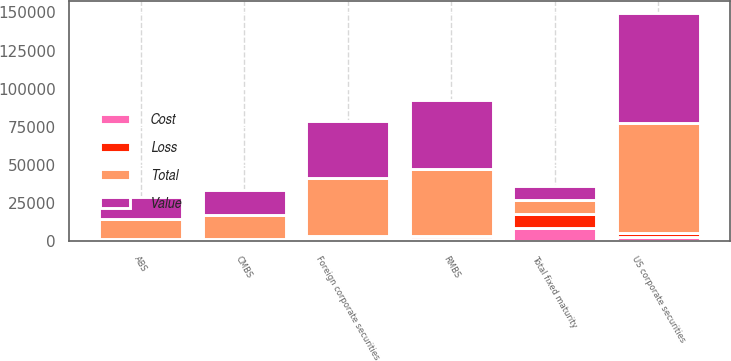Convert chart to OTSL. <chart><loc_0><loc_0><loc_500><loc_500><stacked_bar_chart><ecel><fcel>US corporate securities<fcel>Foreign corporate securities<fcel>RMBS<fcel>CMBS<fcel>ABS<fcel>Total fixed maturity<nl><fcel>Value<fcel>72075<fcel>37254<fcel>45343<fcel>16555<fcel>14272<fcel>9023<nl><fcel>Cost<fcel>2821<fcel>2011<fcel>1234<fcel>191<fcel>189<fcel>8419<nl><fcel>Loss<fcel>2699<fcel>1226<fcel>1957<fcel>1106<fcel>1077<fcel>9627<nl><fcel>Total<fcel>72187<fcel>38030<fcel>44020<fcel>15622<fcel>13162<fcel>9023<nl></chart> 